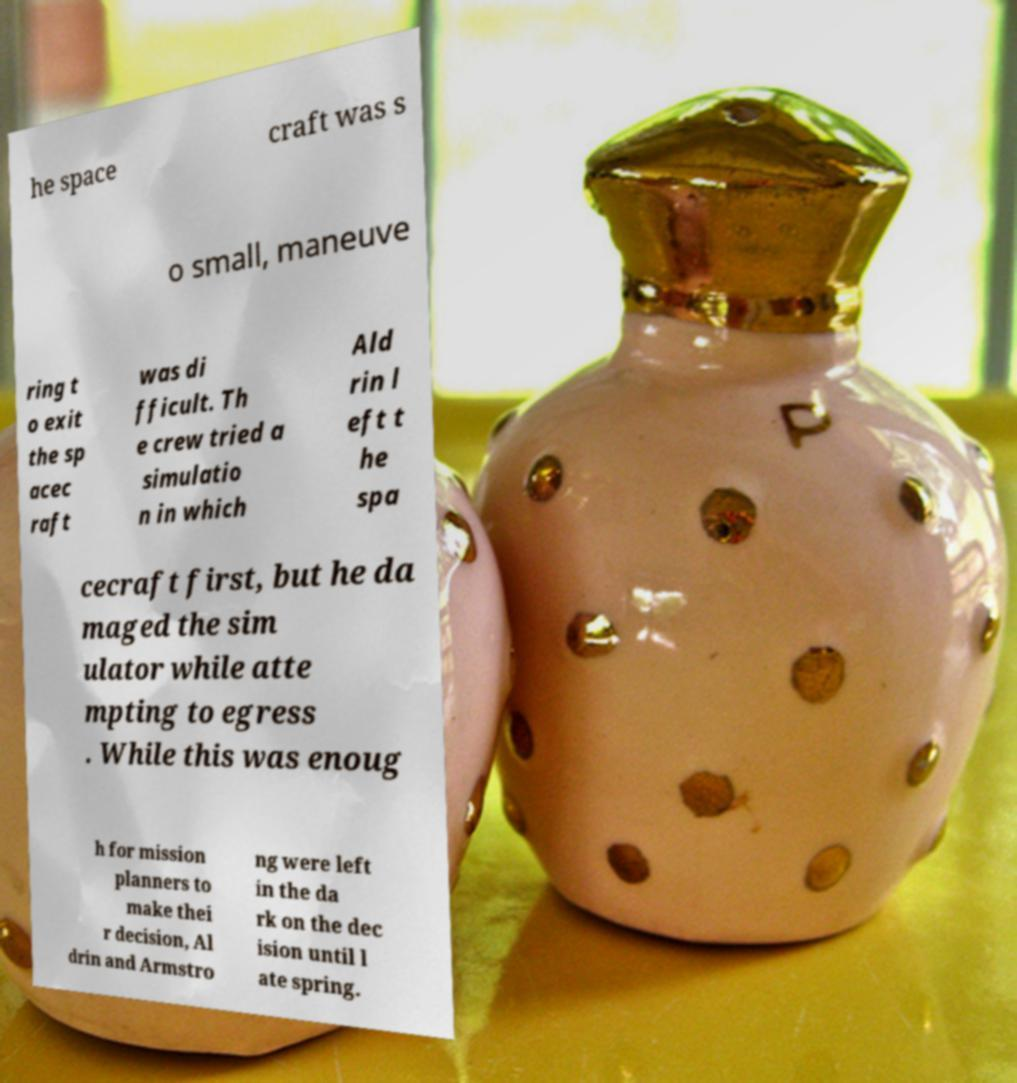What messages or text are displayed in this image? I need them in a readable, typed format. he space craft was s o small, maneuve ring t o exit the sp acec raft was di fficult. Th e crew tried a simulatio n in which Ald rin l eft t he spa cecraft first, but he da maged the sim ulator while atte mpting to egress . While this was enoug h for mission planners to make thei r decision, Al drin and Armstro ng were left in the da rk on the dec ision until l ate spring. 